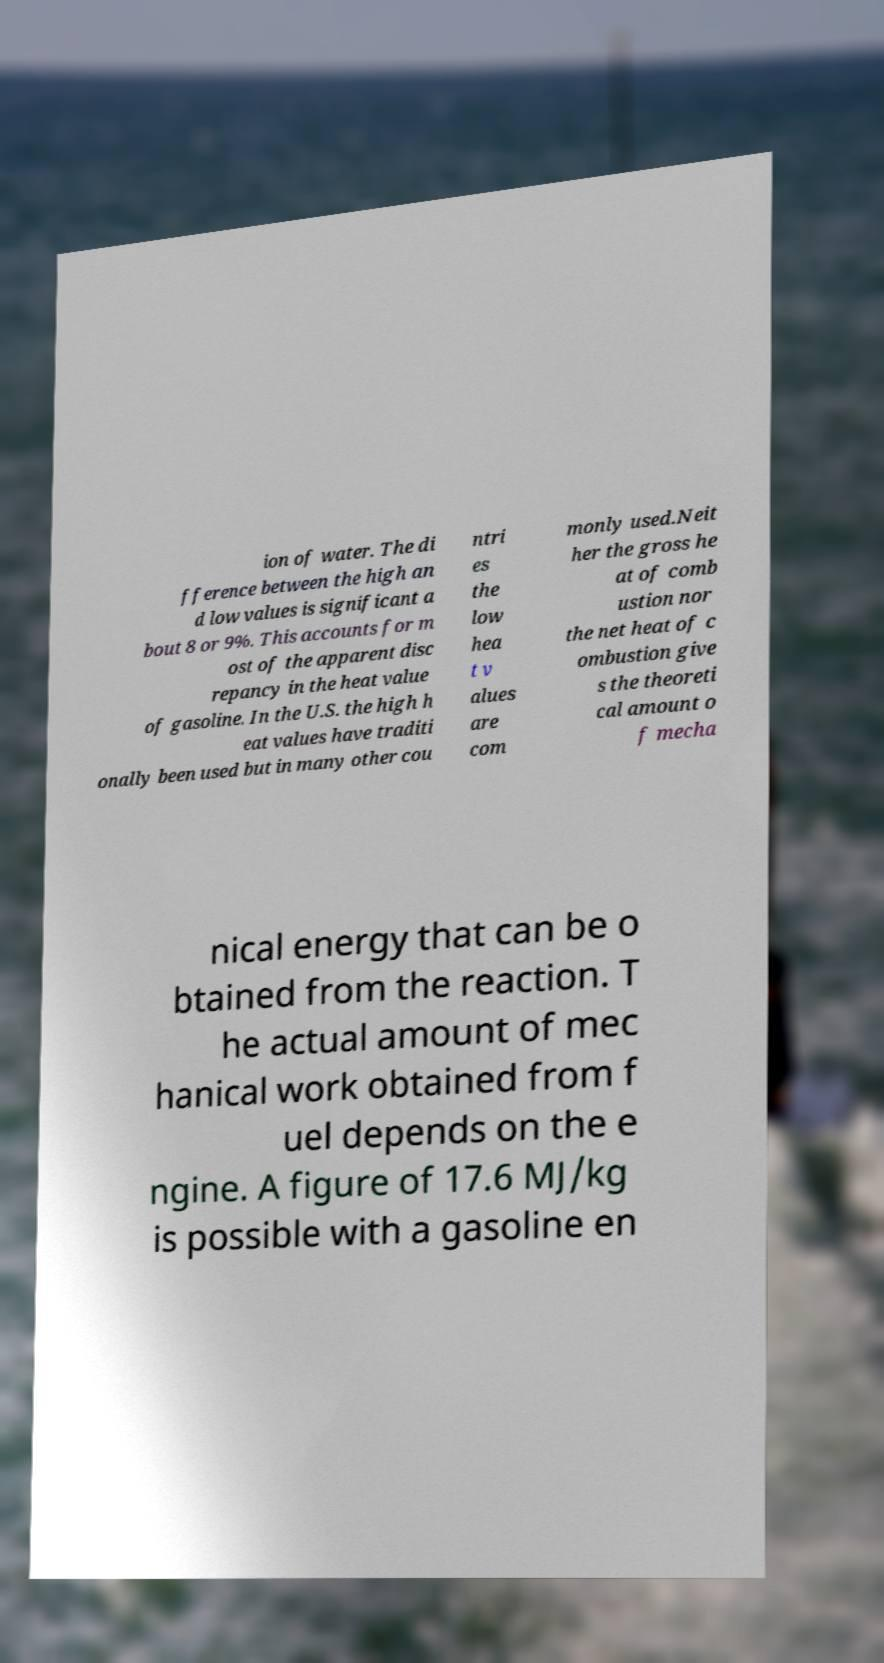Could you assist in decoding the text presented in this image and type it out clearly? ion of water. The di fference between the high an d low values is significant a bout 8 or 9%. This accounts for m ost of the apparent disc repancy in the heat value of gasoline. In the U.S. the high h eat values have traditi onally been used but in many other cou ntri es the low hea t v alues are com monly used.Neit her the gross he at of comb ustion nor the net heat of c ombustion give s the theoreti cal amount o f mecha nical energy that can be o btained from the reaction. T he actual amount of mec hanical work obtained from f uel depends on the e ngine. A figure of 17.6 MJ/kg is possible with a gasoline en 